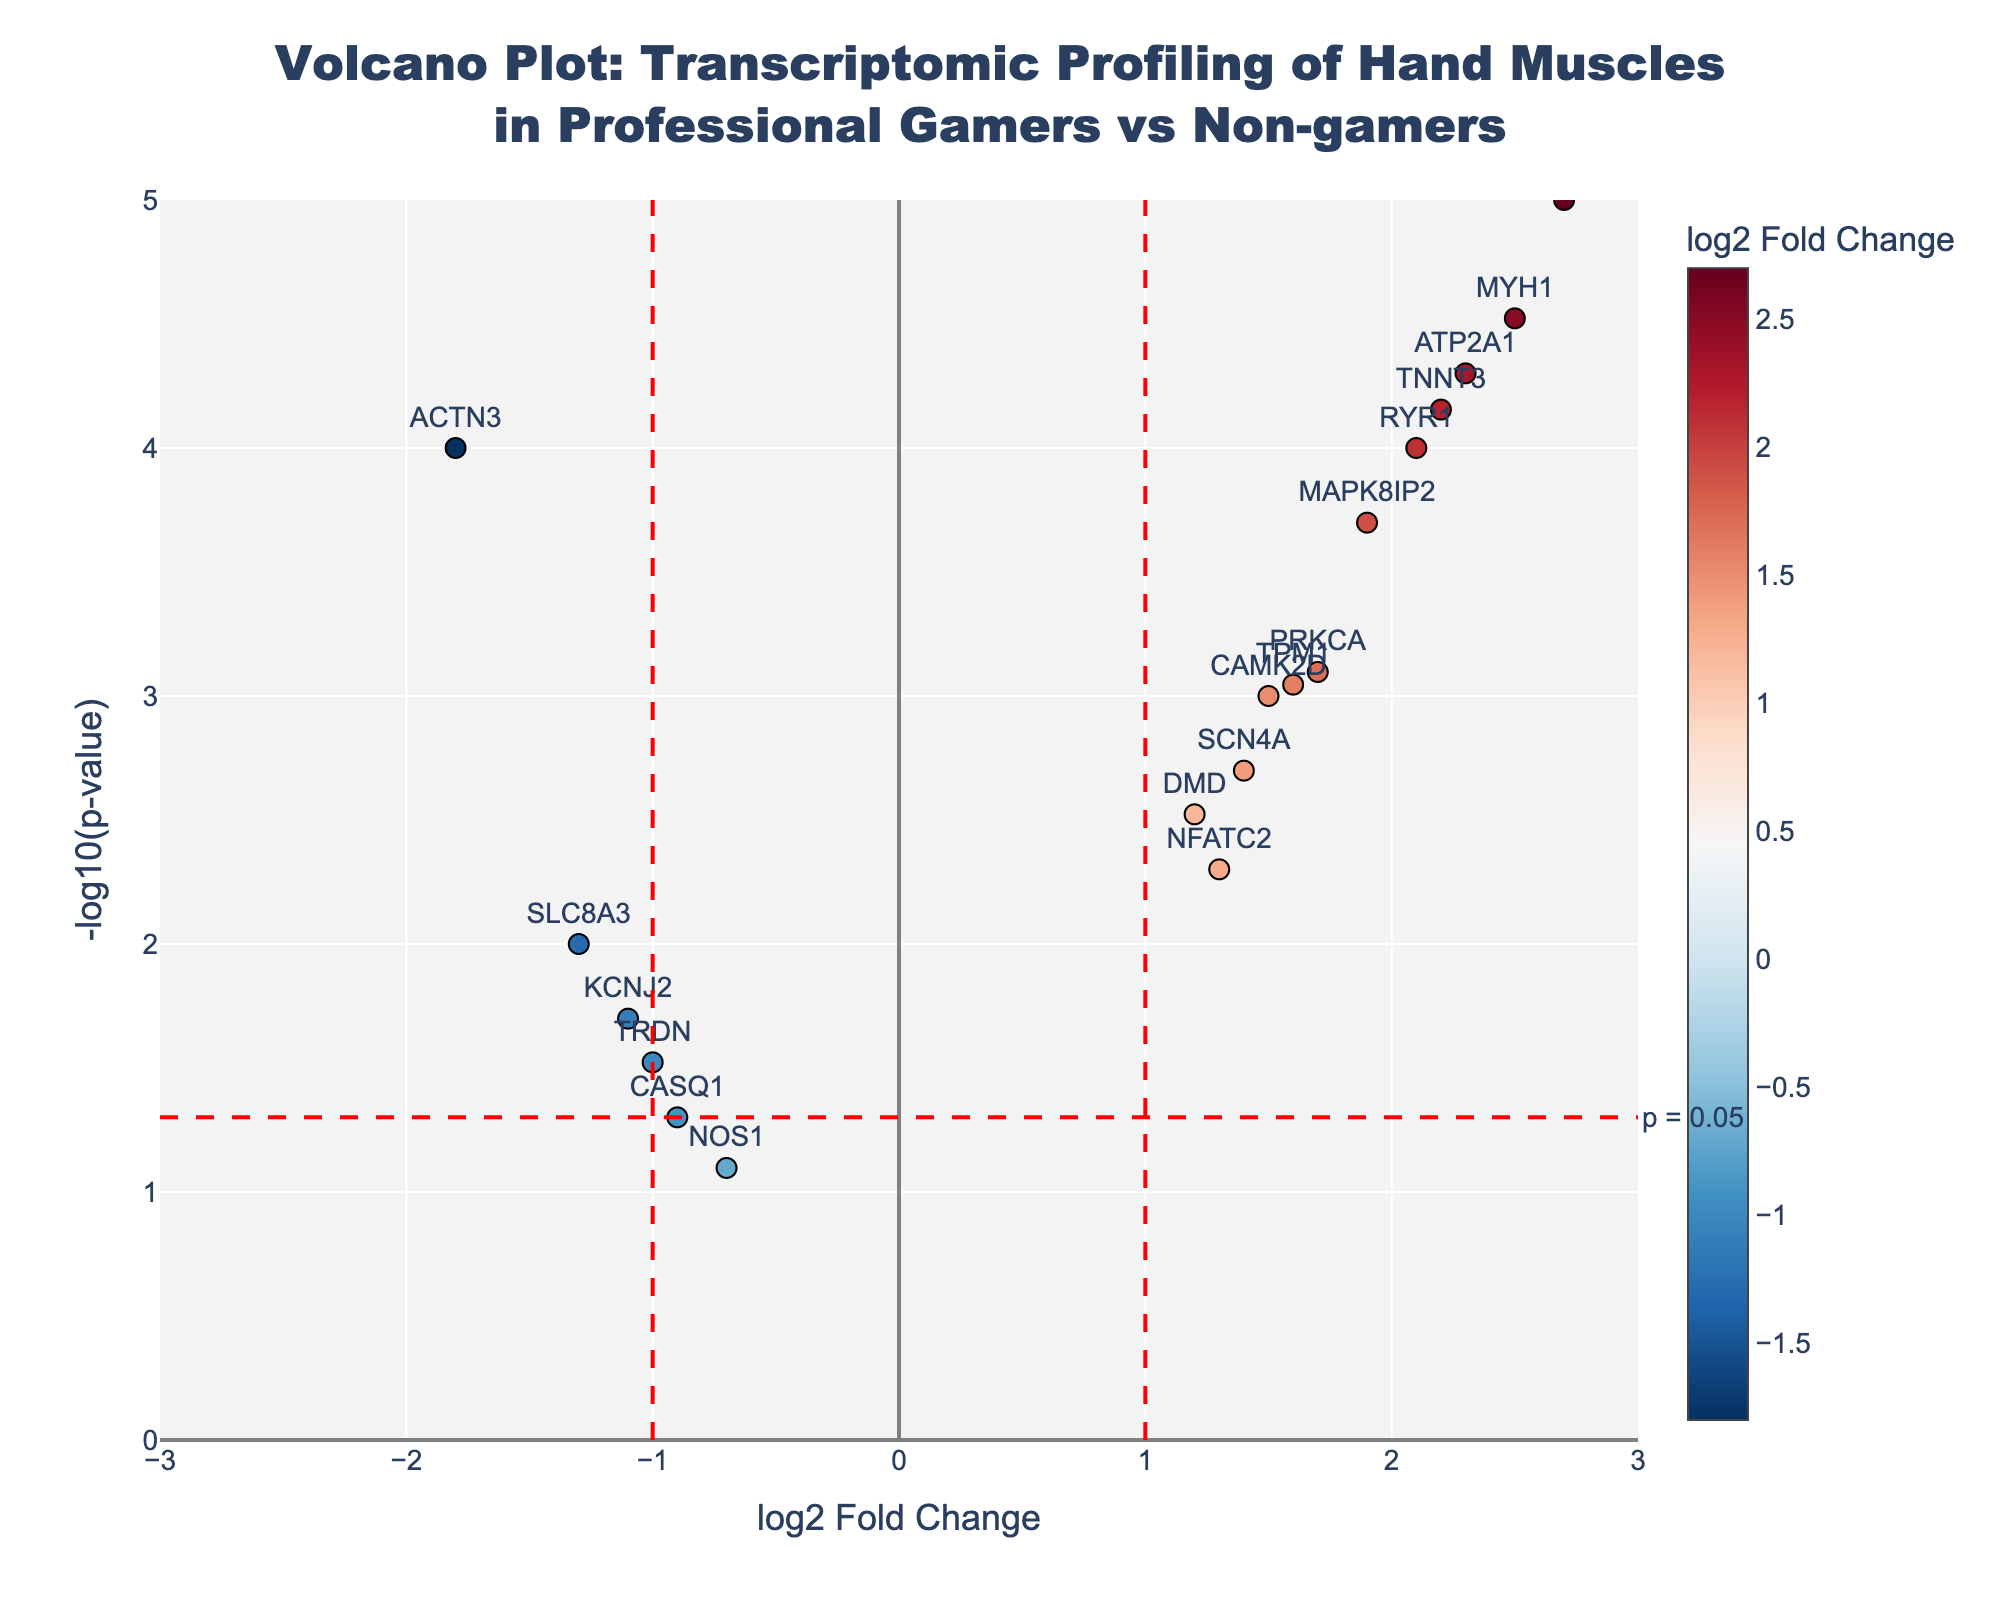Which gene has the most significant change in expression? The most significant change in expression is determined by the gene with the highest -log10(p-value) on the Y-axis. "GRIK2" shows the highest value on this Y-axis, indicating the most significant change.
Answer: GRIK2 How many genes have a log2 fold change greater than 1? Count the genes plotted to the right of the log2 Fold Change = 1 line. According to the figure, these genes are ATP2A1, DMD, GRIK2, MAPK8IP2, MYH1, RYR1, SCN4A, TNNT3, and TPM1.
Answer: 9 Which gene shows the largest downregulation compared to non-gamers? The largest downregulation is represented by the most negative log2 fold change value. According to the plot, this gene is "ACTN3" with a log2 fold change of -1.8.
Answer: ACTN3 Are there any genes that are significantly regulated but have a log2 fold change between -1 and 1? Identify genes within the -1 to 1 log2 fold change region with a -log10(p-value) above the threshold for significance (approximately 1.3). "CASQ1" falls into this category.
Answer: Yes, CASQ1 Which gene has the highest positive fold change? The gene with the highest positive log2 fold change value is "GRIK2" at 2.7.
Answer: GRIK2 How many genes have a p-value less than 0.05? Count the genes with a -log10(p-value) greater than or equal to 1.3, which represents the threshold for p = 0.05. There are 13 such genes in the plot.
Answer: 13 Which gene shows the biggest increase in expression but is not the most significant? Exclude the gene with the highest -log10(p-value) (GRIK2) and find the gene with the next highest log2 fold change. "MYH1" has the next highest log2 fold change of 2.5.
Answer: MYH1 Between ATP2A1 and SCN4A, which gene has a higher significance in change? Compare the -log10(p-value) of ATP2A1 and SCN4A. ATP2A1 has a -log10(p-value) higher than SCN4A.
Answer: ATP2A1 